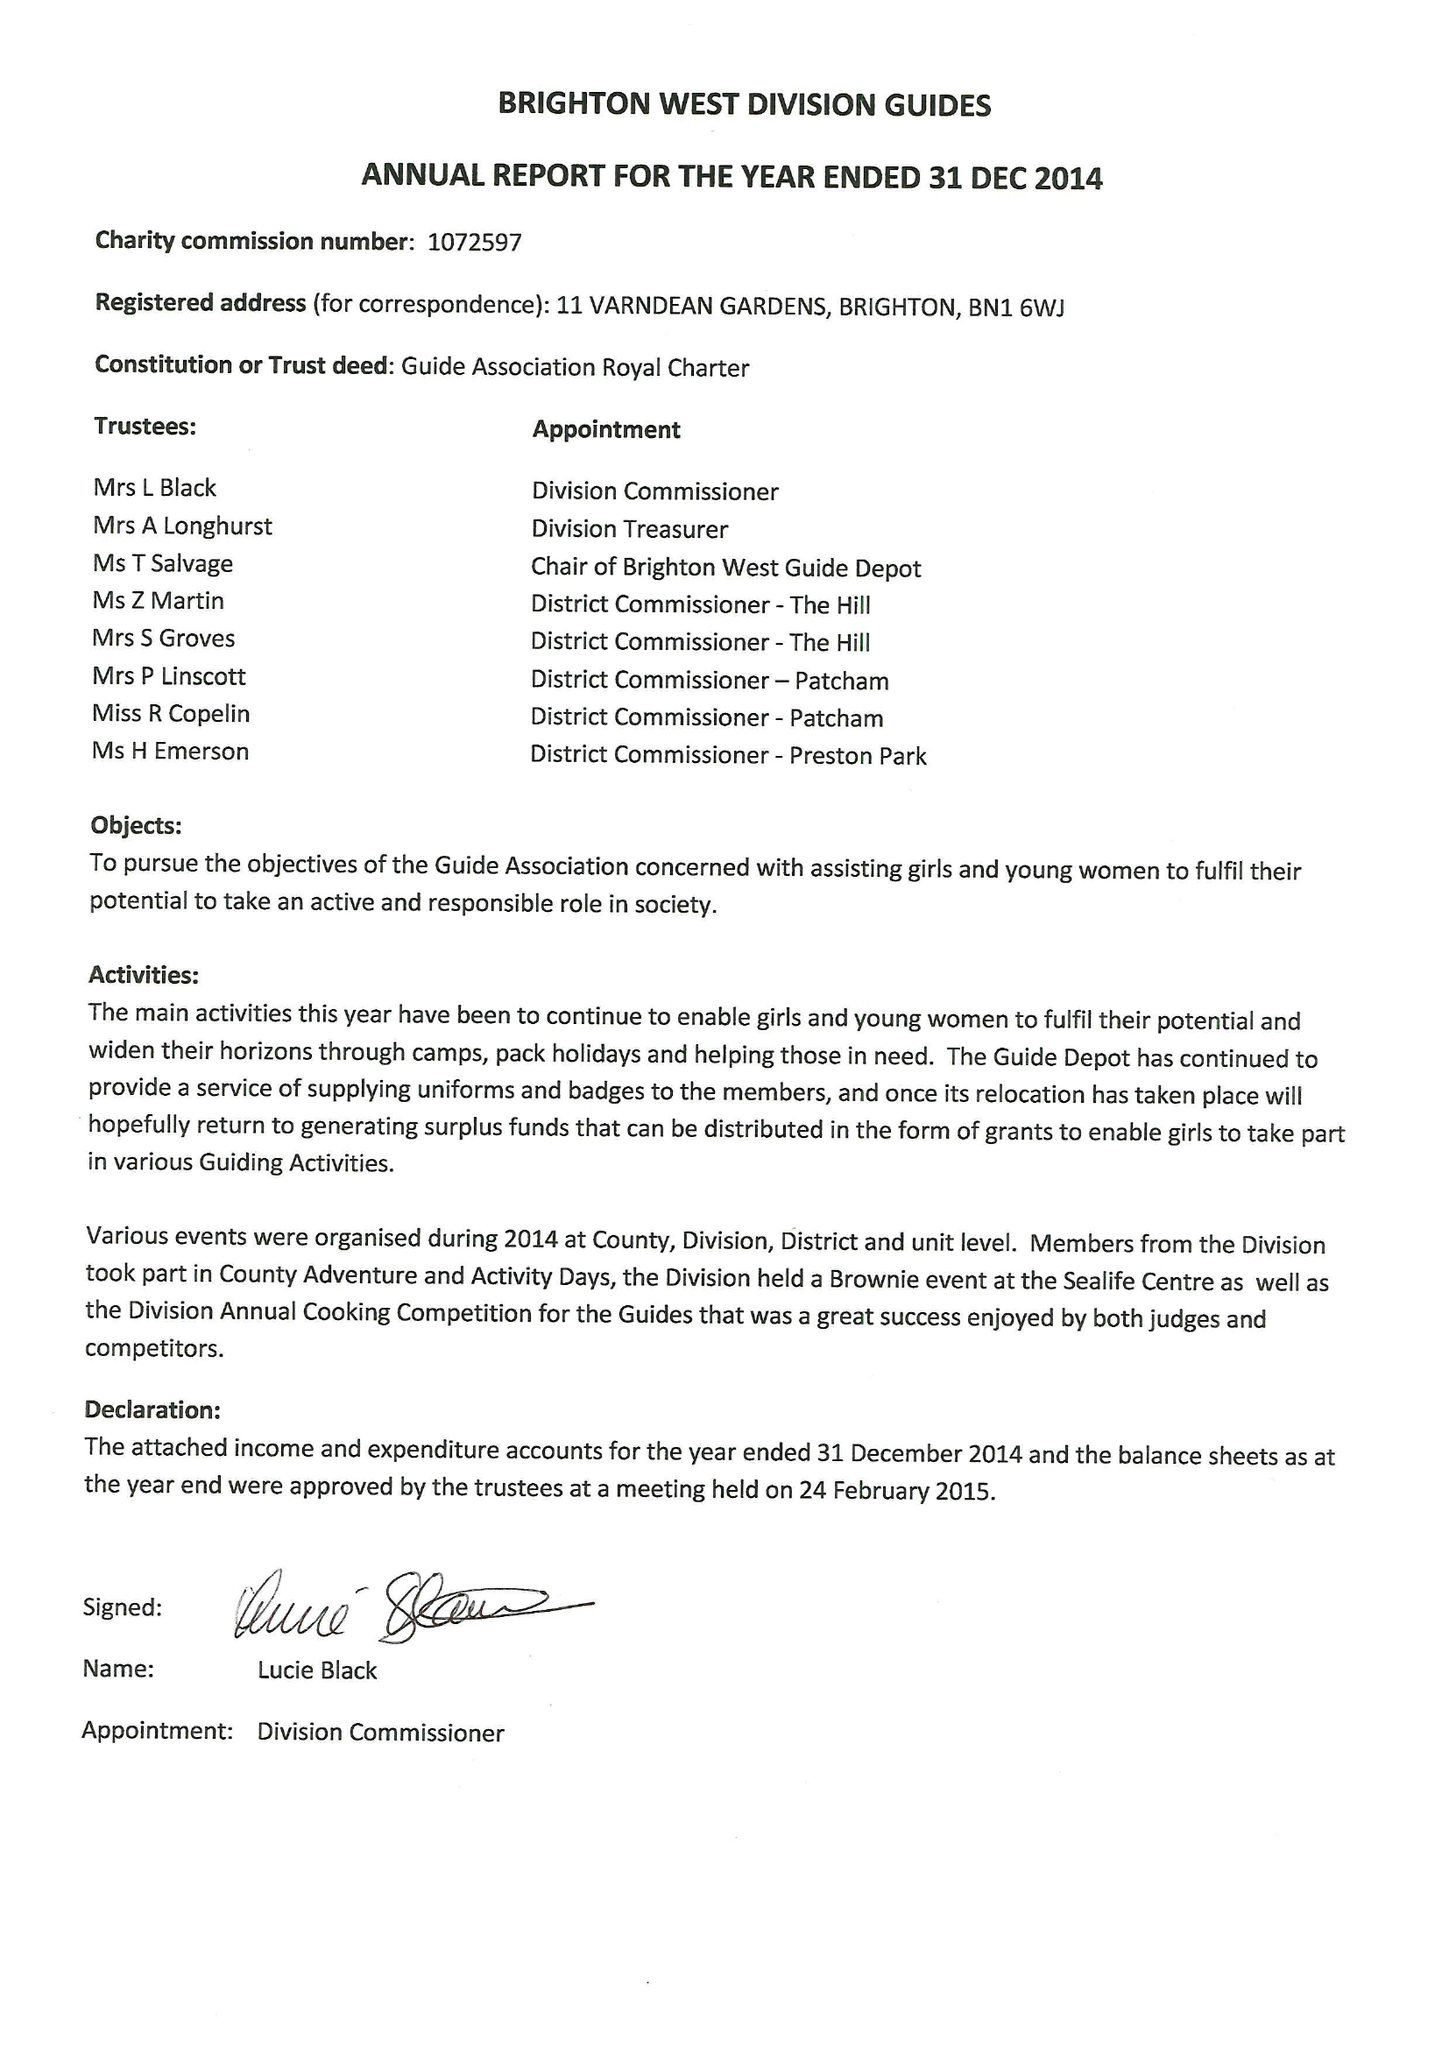What is the value for the charity_number?
Answer the question using a single word or phrase. 1072597 